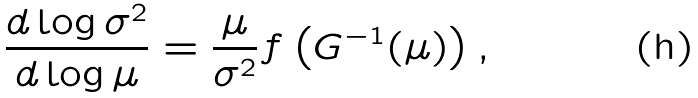<formula> <loc_0><loc_0><loc_500><loc_500>\frac { d \log \sigma ^ { 2 } } { d \log \mu } = \frac { \mu } { \sigma ^ { 2 } } f \left ( G ^ { - 1 } ( \mu ) \right ) ,</formula> 